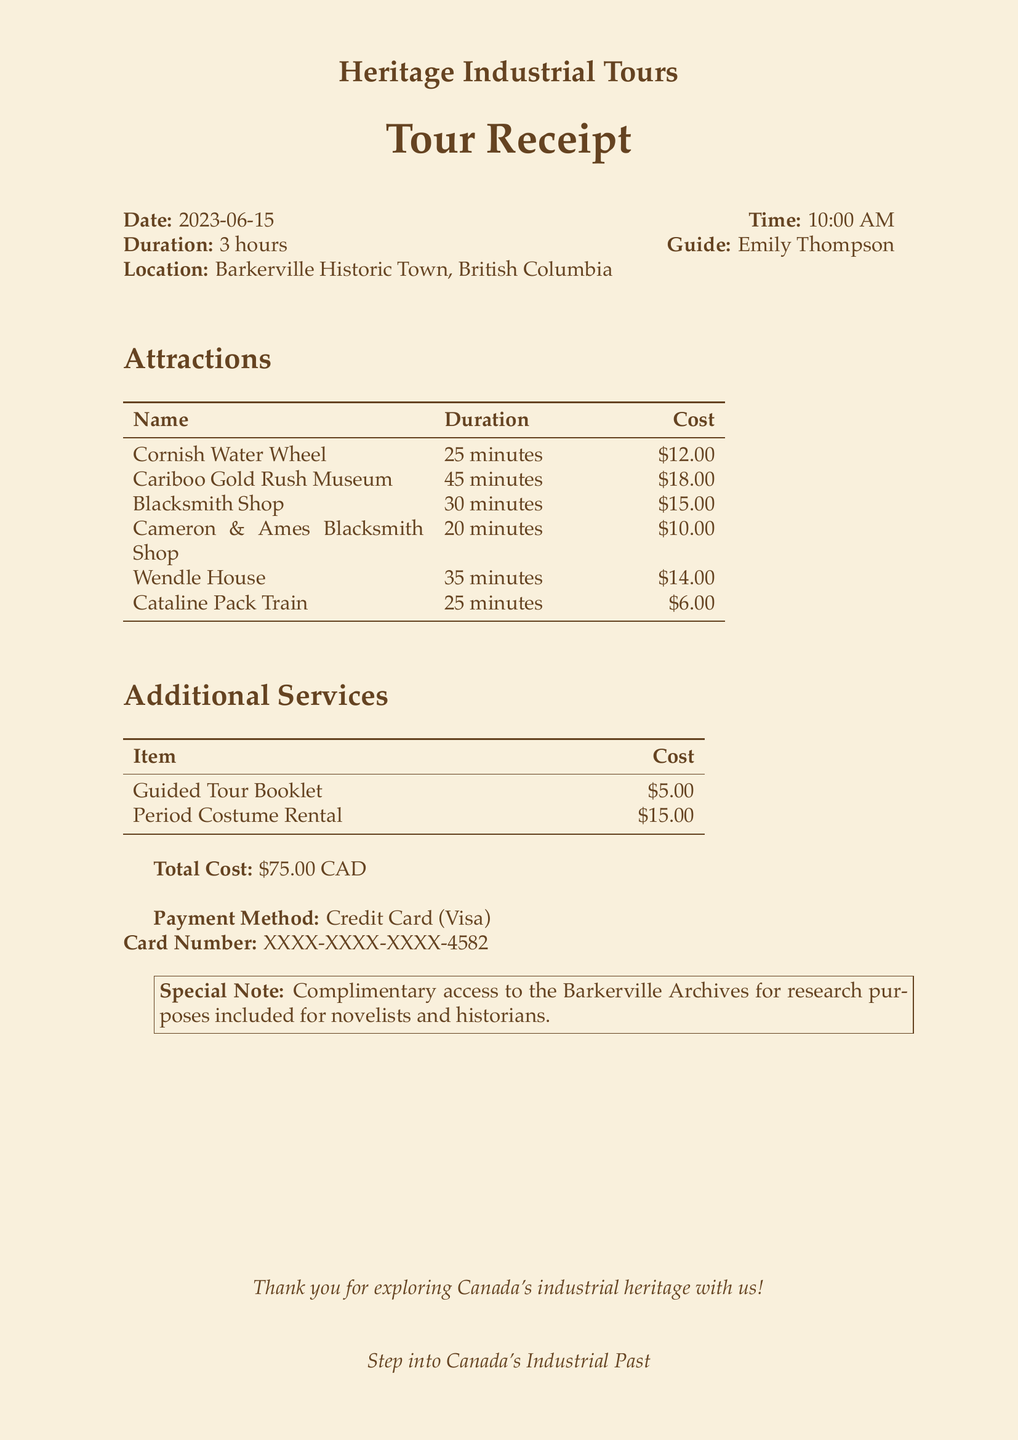What is the name of the tour company? The name of the tour company is provided in the header of the receipt.
Answer: Heritage Industrial Tours What date was the tour conducted? The date of the tour is specified in the document.
Answer: 2023-06-15 Who was the tour guide? The guide's name is listed alongside the tour details.
Answer: Emily Thompson How long was the duration of the tour? The duration of the tour is mentioned in the introductory section of the document.
Answer: 3 hours What is the cost of the Cariboo Gold Rush Museum attraction? Each attraction includes its cost in the table provided.
Answer: $18.00 How many attractions are included in the tour? The total number of attractions can be determined by counting the entries in the attractions section.
Answer: 6 What additional service costs $15.00? The additional services section lists various items with their prices.
Answer: Period Costume Rental What is the total cost for the tour? The total cost is specified at the bottom of the receipt.
Answer: $75.00 CAD What special note is included for novelists and historians? A special note is provided at the end of the document related to research purposes.
Answer: Complimentary access to the Barkerville Archives for research purposes included 